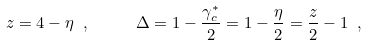<formula> <loc_0><loc_0><loc_500><loc_500>z = 4 - \eta \ , \quad \ \Delta = 1 - \frac { \gamma _ { c } ^ { * } } { 2 } = 1 - \frac { \eta } { 2 } = \frac { z } { 2 } - 1 \ ,</formula> 